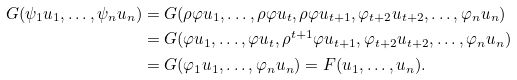Convert formula to latex. <formula><loc_0><loc_0><loc_500><loc_500>G ( \psi _ { 1 } u _ { 1 } , \dots , \psi _ { n } u _ { n } ) & = G ( \rho \varphi u _ { 1 } , \dots , \rho \varphi u _ { t } , \rho \varphi u _ { t + 1 } , \varphi _ { t + 2 } u _ { t + 2 } , \dots , \varphi _ { n } u _ { n } ) \\ & = G ( \varphi u _ { 1 } , \dots , \varphi u _ { t } , \rho ^ { t + 1 } \varphi u _ { t + 1 } , \varphi _ { t + 2 } u _ { t + 2 } , \dots , \varphi _ { n } u _ { n } ) \\ & = G ( \varphi _ { 1 } u _ { 1 } , \dots , \varphi _ { n } u _ { n } ) = F ( u _ { 1 } , \dots , u _ { n } ) .</formula> 